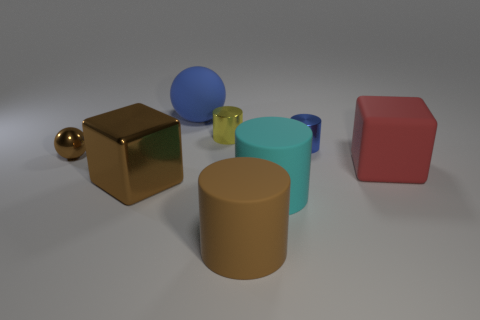Subtract all blue cylinders. How many cylinders are left? 3 Add 2 tiny brown rubber balls. How many objects exist? 10 Subtract all green cylinders. Subtract all red balls. How many cylinders are left? 4 Subtract all blocks. How many objects are left? 6 Add 2 large spheres. How many large spheres exist? 3 Subtract 0 red spheres. How many objects are left? 8 Subtract all small blue blocks. Subtract all blue metallic cylinders. How many objects are left? 7 Add 5 big cyan rubber cylinders. How many big cyan rubber cylinders are left? 6 